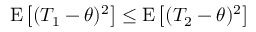Convert formula to latex. <formula><loc_0><loc_0><loc_500><loc_500>E \left [ ( T _ { 1 } - \theta ) ^ { 2 } \right ] \leq E \left [ ( T _ { 2 } - \theta ) ^ { 2 } \right ]</formula> 